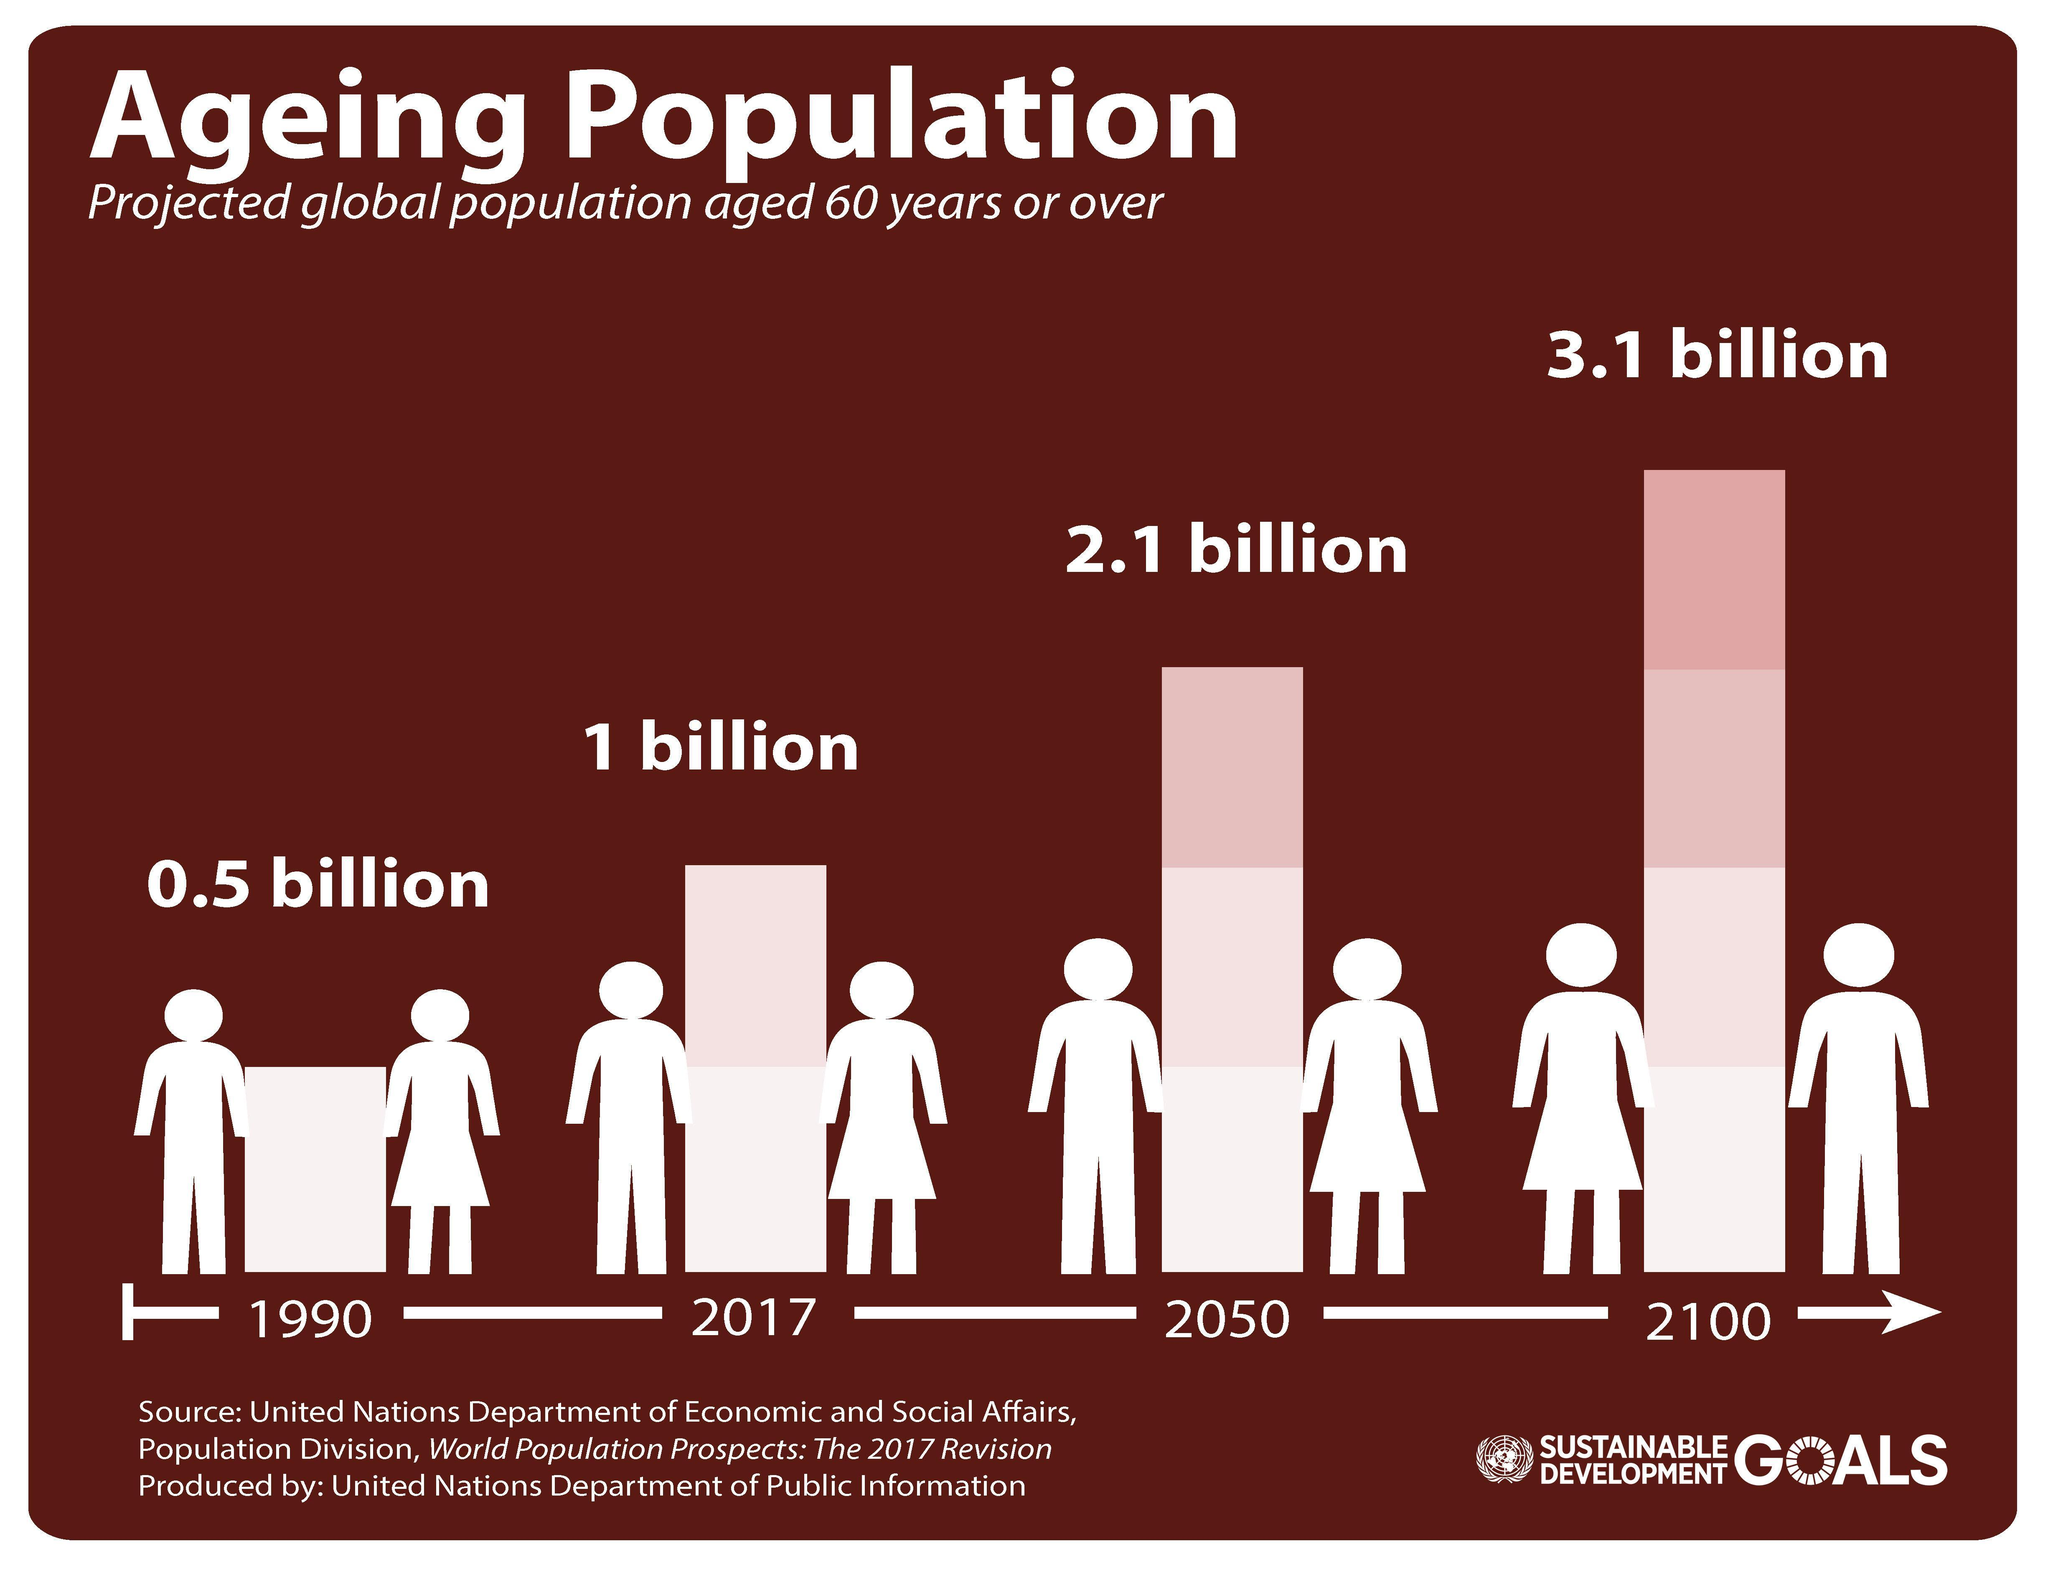What is the difference between the aging population in 2100 and 2017?
Answer the question with a short phrase. 2.1 billion What is the difference between the aging population in 2017 and 1990? 0.5 billion What is the difference between the aging population in 2100 and 2050? 1 billion What is the difference between the aging population in 2100 and 1990? 2.6 billion What is the difference between the aging population in 2050 and 2017? 1.1 billion 